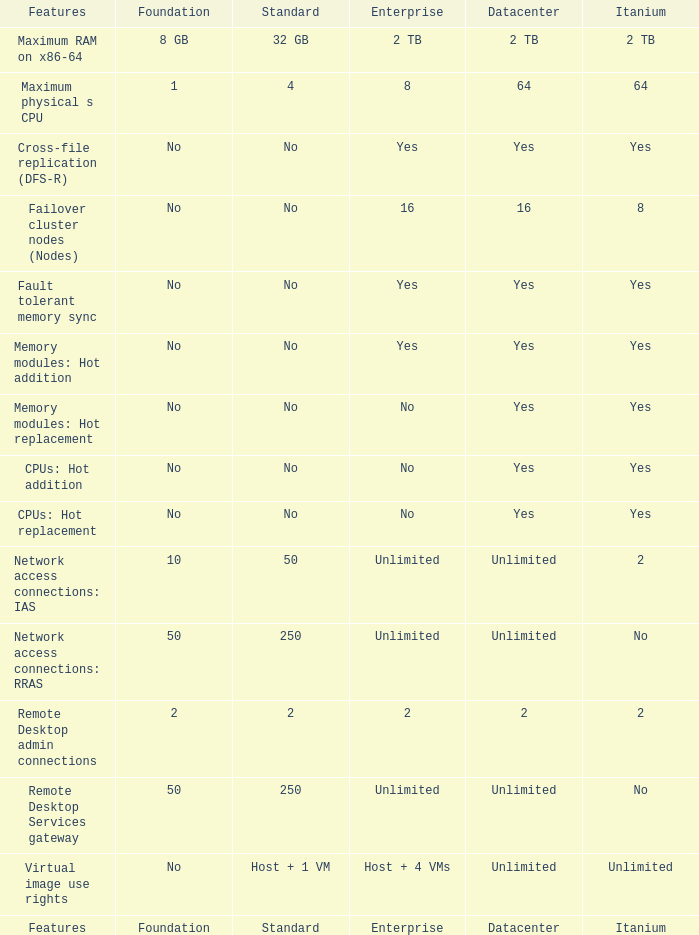Which Foundation has an Enterprise of 2? 2.0. 